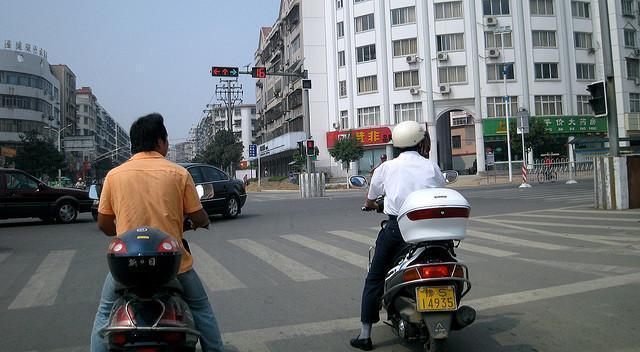How many cars are there?
Give a very brief answer. 3. How many motorcycles are in the photo?
Give a very brief answer. 2. How many people are in the photo?
Give a very brief answer. 2. 